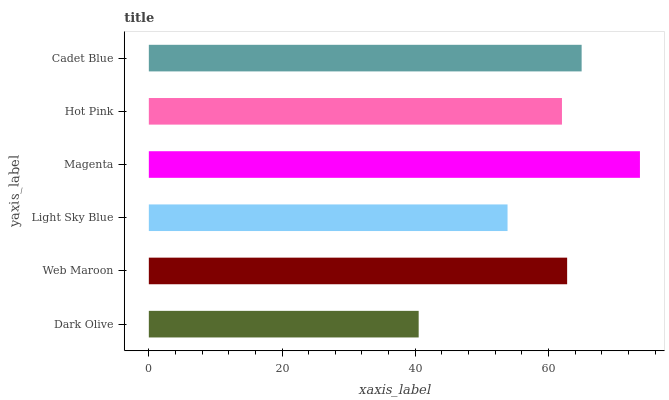Is Dark Olive the minimum?
Answer yes or no. Yes. Is Magenta the maximum?
Answer yes or no. Yes. Is Web Maroon the minimum?
Answer yes or no. No. Is Web Maroon the maximum?
Answer yes or no. No. Is Web Maroon greater than Dark Olive?
Answer yes or no. Yes. Is Dark Olive less than Web Maroon?
Answer yes or no. Yes. Is Dark Olive greater than Web Maroon?
Answer yes or no. No. Is Web Maroon less than Dark Olive?
Answer yes or no. No. Is Web Maroon the high median?
Answer yes or no. Yes. Is Hot Pink the low median?
Answer yes or no. Yes. Is Light Sky Blue the high median?
Answer yes or no. No. Is Web Maroon the low median?
Answer yes or no. No. 